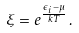<formula> <loc_0><loc_0><loc_500><loc_500>\xi = e ^ { \frac { \epsilon _ { i } - \mu } { k T } } \, .</formula> 